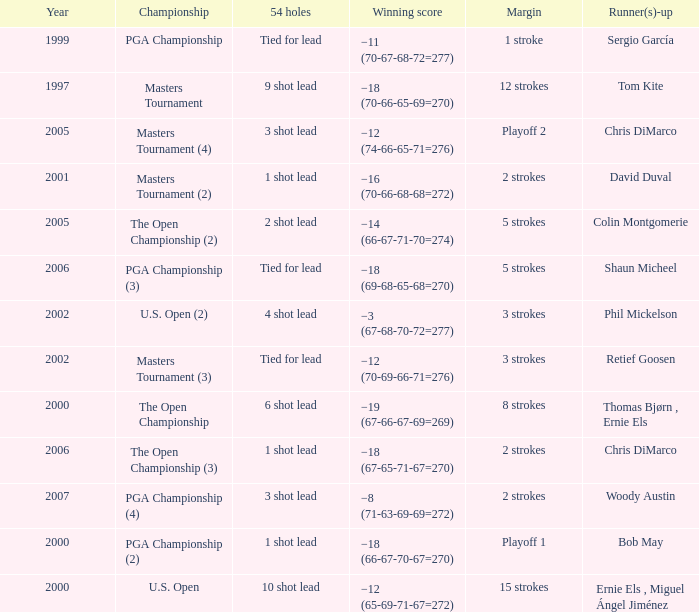What is the minimum year where winning score is −8 (71-63-69-69=272) 2007.0. Give me the full table as a dictionary. {'header': ['Year', 'Championship', '54 holes', 'Winning score', 'Margin', 'Runner(s)-up'], 'rows': [['1999', 'PGA Championship', 'Tied for lead', '−11 (70-67-68-72=277)', '1 stroke', 'Sergio García'], ['1997', 'Masters Tournament', '9 shot lead', '−18 (70-66-65-69=270)', '12 strokes', 'Tom Kite'], ['2005', 'Masters Tournament (4)', '3 shot lead', '−12 (74-66-65-71=276)', 'Playoff 2', 'Chris DiMarco'], ['2001', 'Masters Tournament (2)', '1 shot lead', '−16 (70-66-68-68=272)', '2 strokes', 'David Duval'], ['2005', 'The Open Championship (2)', '2 shot lead', '−14 (66-67-71-70=274)', '5 strokes', 'Colin Montgomerie'], ['2006', 'PGA Championship (3)', 'Tied for lead', '−18 (69-68-65-68=270)', '5 strokes', 'Shaun Micheel'], ['2002', 'U.S. Open (2)', '4 shot lead', '−3 (67-68-70-72=277)', '3 strokes', 'Phil Mickelson'], ['2002', 'Masters Tournament (3)', 'Tied for lead', '−12 (70-69-66-71=276)', '3 strokes', 'Retief Goosen'], ['2000', 'The Open Championship', '6 shot lead', '−19 (67-66-67-69=269)', '8 strokes', 'Thomas Bjørn , Ernie Els'], ['2006', 'The Open Championship (3)', '1 shot lead', '−18 (67-65-71-67=270)', '2 strokes', 'Chris DiMarco'], ['2007', 'PGA Championship (4)', '3 shot lead', '−8 (71-63-69-69=272)', '2 strokes', 'Woody Austin'], ['2000', 'PGA Championship (2)', '1 shot lead', '−18 (66-67-70-67=270)', 'Playoff 1', 'Bob May'], ['2000', 'U.S. Open', '10 shot lead', '−12 (65-69-71-67=272)', '15 strokes', 'Ernie Els , Miguel Ángel Jiménez']]} 